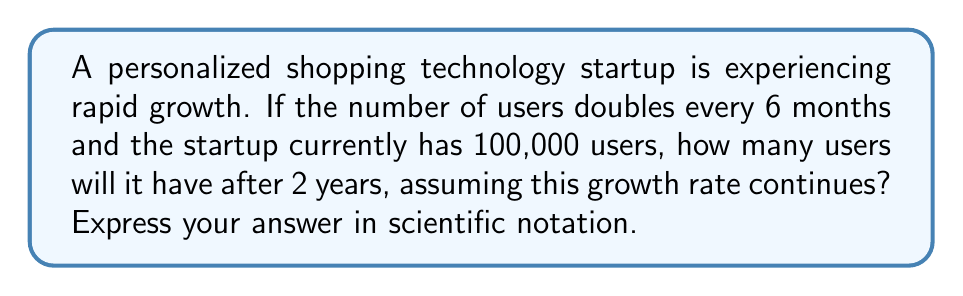Can you answer this question? Let's approach this step-by-step:

1) First, we need to determine how many times the user base will double in 2 years:
   - In 6 months, the user base doubles once
   - In 1 year, it doubles twice
   - In 2 years, it doubles 4 times

2) We can express this mathematically as:
   $$\text{Users after 2 years} = 100,000 \times 2^4$$

3) Let's calculate:
   $$100,000 \times 2^4 = 100,000 \times 16 = 1,600,000$$

4) To express this in scientific notation, we move the decimal point 6 places to the left:
   $$1,600,000 = 1.6 \times 10^6$$

This exponential growth model demonstrates the potential rapid expansion of the market for personalized shopping technology, which is crucial information for a venture capitalist considering investment in this sector.
Answer: $1.6 \times 10^6$ 